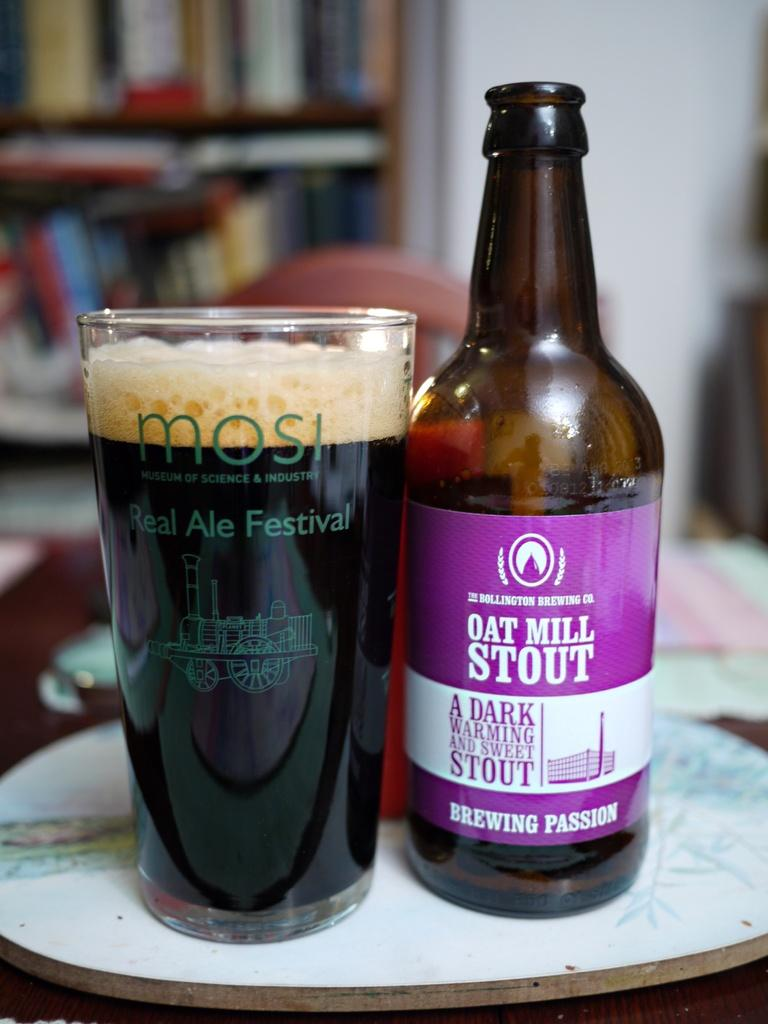<image>
Render a clear and concise summary of the photo. A bottle of oat mill stout next to a class from the real ale festival 